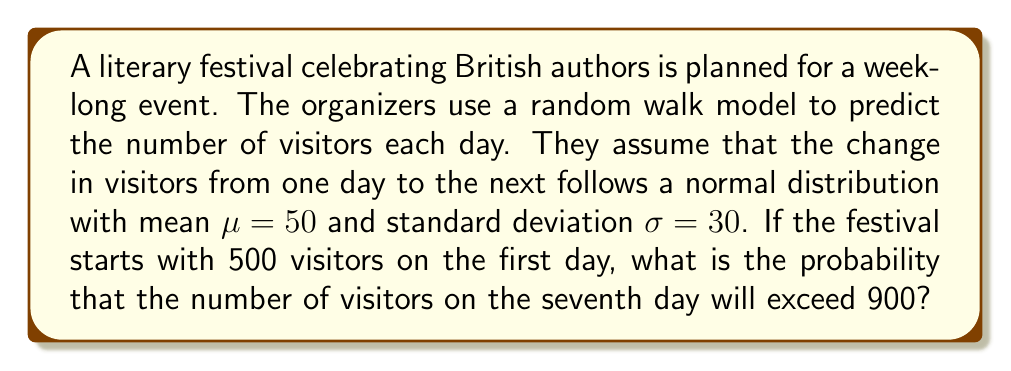Can you answer this question? Let's approach this step-by-step:

1) We are dealing with a random walk model where the daily change in visitors follows a normal distribution $N(\mu, \sigma^2)$ with $\mu = 50$ and $\sigma = 30$.

2) Over 6 days (to get from day 1 to day 7), the total change in visitors will also follow a normal distribution. Let's call this total change $X$.

3) The mean of $X$ will be $6\mu = 6 \times 50 = 300$, as we're summing 6 daily changes.

4) The variance of $X$ will be $6\sigma^2 = 6 \times 30^2 = 5400$, as variances add for independent normal variables.

5) So, $X \sim N(300, 5400)$

6) The number of visitors on day 7 will be $500 + X$, where 500 is the initial number of visitors.

7) We want to find $P(500 + X > 900)$, which is equivalent to $P(X > 400)$

8) We can standardize this:

   $$Z = \frac{X - \mu}{\sigma} = \frac{400 - 300}{\sqrt{5400}} = \frac{100}{\sqrt{5400}} \approx 1.36$$

9) We need to find $P(Z > 1.36)$

10) Using a standard normal table or calculator, we can find that $P(Z > 1.36) \approx 0.0869$

Therefore, the probability that the number of visitors on the seventh day will exceed 900 is approximately 0.0869 or 8.69%.
Answer: 0.0869 